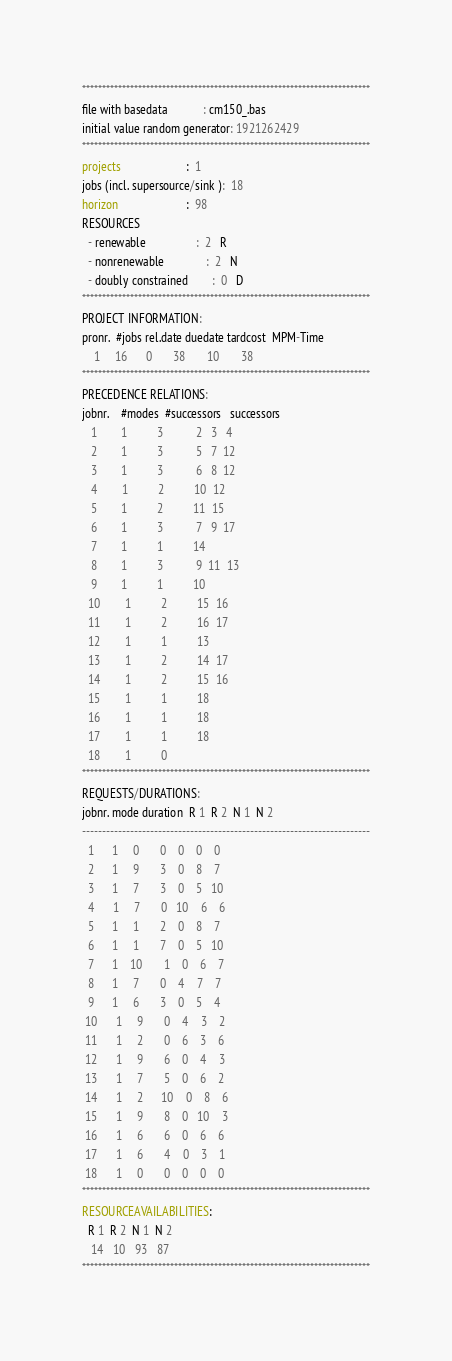Convert code to text. <code><loc_0><loc_0><loc_500><loc_500><_ObjectiveC_>************************************************************************
file with basedata            : cm150_.bas
initial value random generator: 1921262429
************************************************************************
projects                      :  1
jobs (incl. supersource/sink ):  18
horizon                       :  98
RESOURCES
  - renewable                 :  2   R
  - nonrenewable              :  2   N
  - doubly constrained        :  0   D
************************************************************************
PROJECT INFORMATION:
pronr.  #jobs rel.date duedate tardcost  MPM-Time
    1     16      0       38       10       38
************************************************************************
PRECEDENCE RELATIONS:
jobnr.    #modes  #successors   successors
   1        1          3           2   3   4
   2        1          3           5   7  12
   3        1          3           6   8  12
   4        1          2          10  12
   5        1          2          11  15
   6        1          3           7   9  17
   7        1          1          14
   8        1          3           9  11  13
   9        1          1          10
  10        1          2          15  16
  11        1          2          16  17
  12        1          1          13
  13        1          2          14  17
  14        1          2          15  16
  15        1          1          18
  16        1          1          18
  17        1          1          18
  18        1          0        
************************************************************************
REQUESTS/DURATIONS:
jobnr. mode duration  R 1  R 2  N 1  N 2
------------------------------------------------------------------------
  1      1     0       0    0    0    0
  2      1     9       3    0    8    7
  3      1     7       3    0    5   10
  4      1     7       0   10    6    6
  5      1     1       2    0    8    7
  6      1     1       7    0    5   10
  7      1    10       1    0    6    7
  8      1     7       0    4    7    7
  9      1     6       3    0    5    4
 10      1     9       0    4    3    2
 11      1     2       0    6    3    6
 12      1     9       6    0    4    3
 13      1     7       5    0    6    2
 14      1     2      10    0    8    6
 15      1     9       8    0   10    3
 16      1     6       6    0    6    6
 17      1     6       4    0    3    1
 18      1     0       0    0    0    0
************************************************************************
RESOURCEAVAILABILITIES:
  R 1  R 2  N 1  N 2
   14   10   93   87
************************************************************************
</code> 